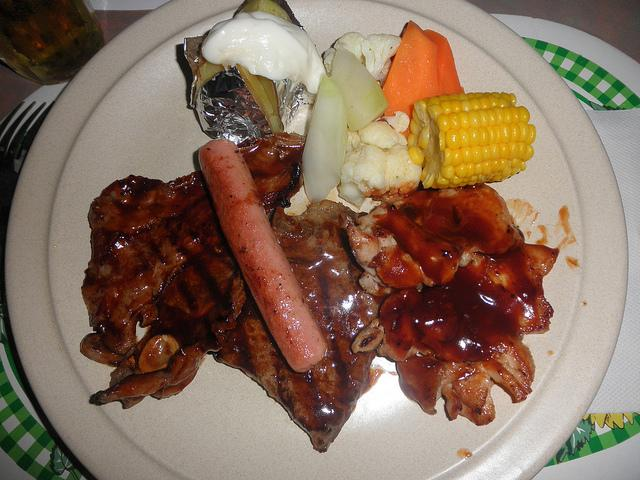Which dairy product is most prominent here? sour cream 